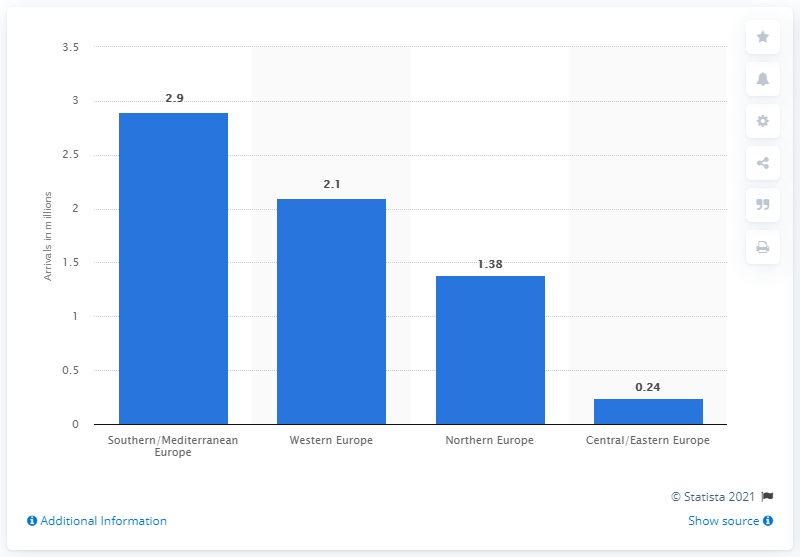Mention a couple of crucial points in this snapshot. In 2019, 2.9 million Canadian tourists visited Southern/Mediterranean Europe. In 2019, Western Europe reported 2.1 trips from Canada, according to their official statistics. According to data from 2019, the Southern/Mediterranean region of Europe was the most visited by Canadian tourists. 